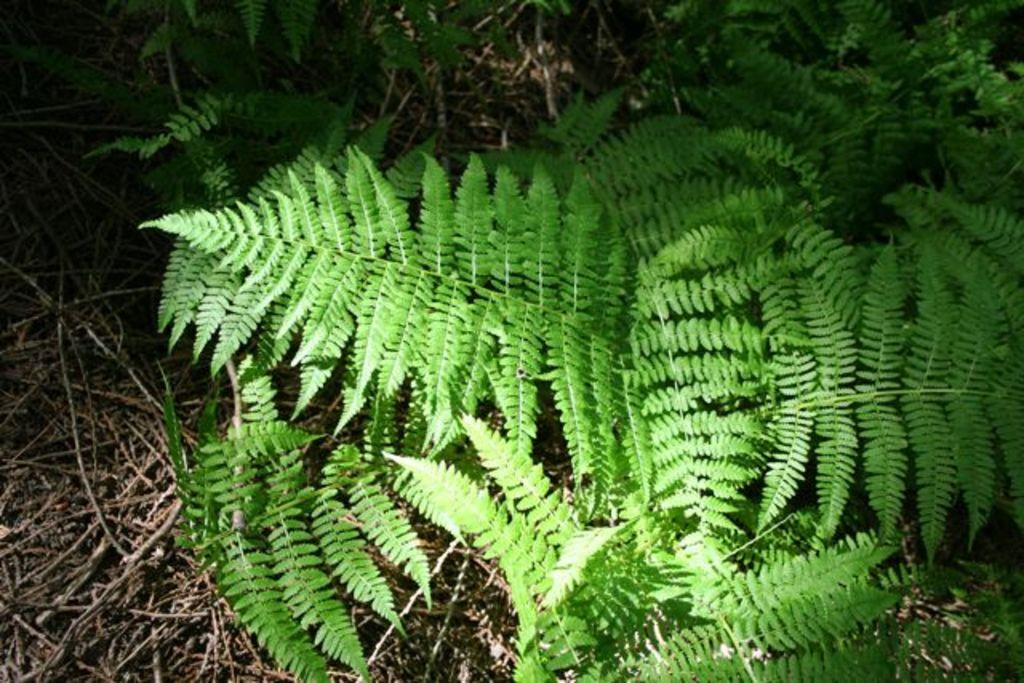What type of vegetation is present in the image? There are green plants in the image. What else can be seen in the image besides the plants? There are sticks in the image. Is there any snow visible in the image? No, there is no snow present in the image. What type of room can be seen in the image? There is no room visible in the image; it only features green plants and sticks. 